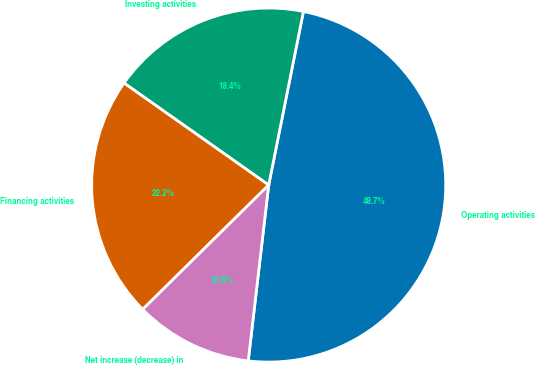Convert chart to OTSL. <chart><loc_0><loc_0><loc_500><loc_500><pie_chart><fcel>Operating activities<fcel>Investing activities<fcel>Financing activities<fcel>Net increase (decrease) in<nl><fcel>48.7%<fcel>18.37%<fcel>22.17%<fcel>10.76%<nl></chart> 